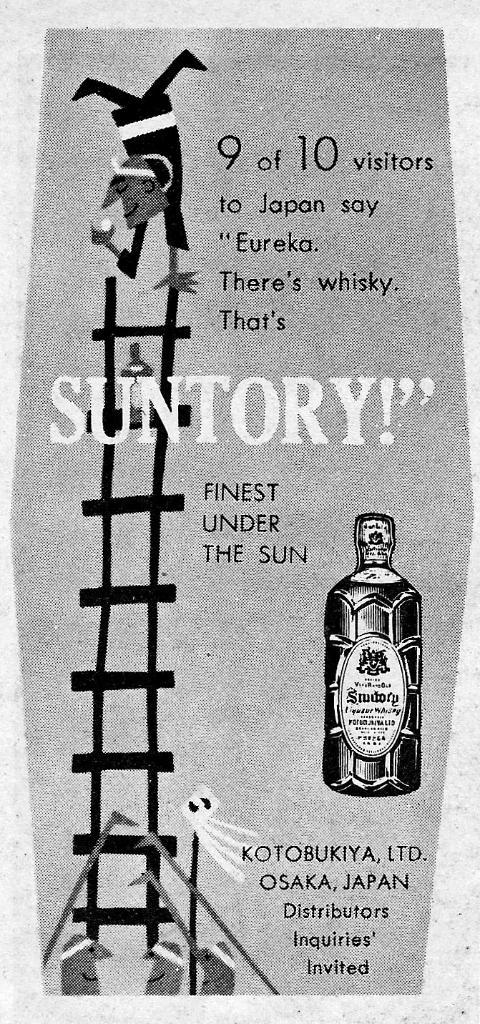What is this advertisement for?
Your answer should be compact. Suntory. Is this the finest under the sun?
Give a very brief answer. Yes. 